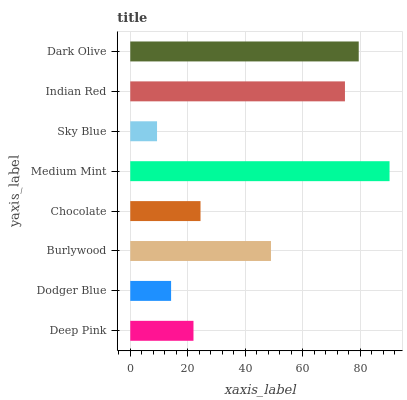Is Sky Blue the minimum?
Answer yes or no. Yes. Is Medium Mint the maximum?
Answer yes or no. Yes. Is Dodger Blue the minimum?
Answer yes or no. No. Is Dodger Blue the maximum?
Answer yes or no. No. Is Deep Pink greater than Dodger Blue?
Answer yes or no. Yes. Is Dodger Blue less than Deep Pink?
Answer yes or no. Yes. Is Dodger Blue greater than Deep Pink?
Answer yes or no. No. Is Deep Pink less than Dodger Blue?
Answer yes or no. No. Is Burlywood the high median?
Answer yes or no. Yes. Is Chocolate the low median?
Answer yes or no. Yes. Is Chocolate the high median?
Answer yes or no. No. Is Dark Olive the low median?
Answer yes or no. No. 